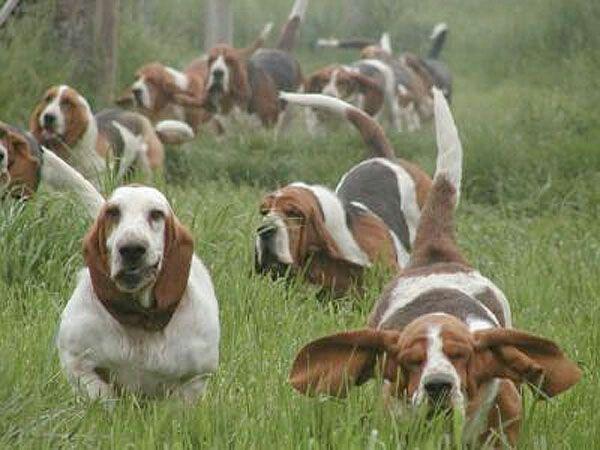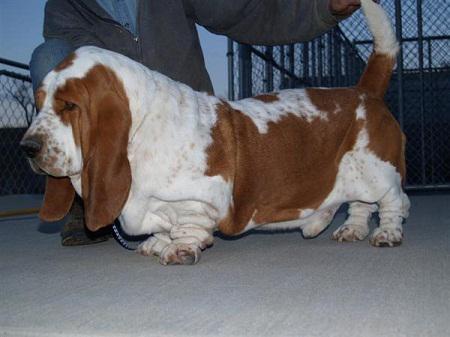The first image is the image on the left, the second image is the image on the right. For the images shown, is this caption "At least one dog is laying down." true? Answer yes or no. No. The first image is the image on the left, the second image is the image on the right. Evaluate the accuracy of this statement regarding the images: "In one of the images, there are at least four dogs.". Is it true? Answer yes or no. Yes. 